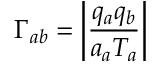Convert formula to latex. <formula><loc_0><loc_0><loc_500><loc_500>\Gamma _ { a b } = \left | \frac { q _ { a } q _ { b } } { a _ { a } T _ { a } } \right |</formula> 